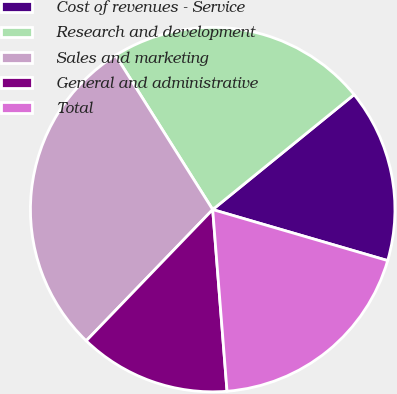Convert chart to OTSL. <chart><loc_0><loc_0><loc_500><loc_500><pie_chart><fcel>Cost of revenues - Service<fcel>Research and development<fcel>Sales and marketing<fcel>General and administrative<fcel>Total<nl><fcel>15.38%<fcel>23.08%<fcel>28.85%<fcel>13.46%<fcel>19.23%<nl></chart> 